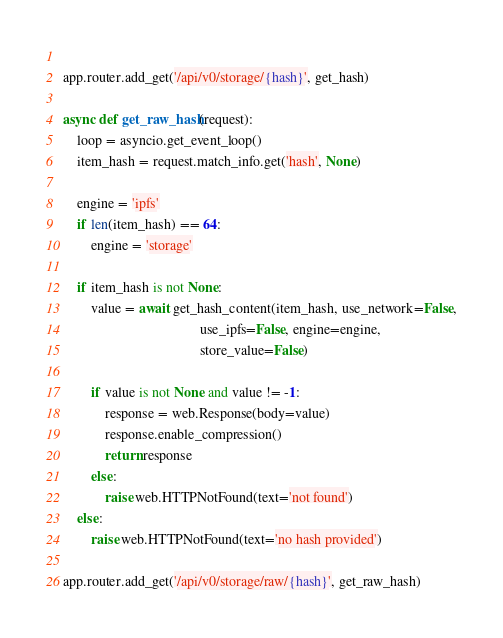Convert code to text. <code><loc_0><loc_0><loc_500><loc_500><_Python_>    
app.router.add_get('/api/v0/storage/{hash}', get_hash)

async def get_raw_hash(request):
    loop = asyncio.get_event_loop()
    item_hash = request.match_info.get('hash', None)
    
    engine = 'ipfs'
    if len(item_hash) == 64:
        engine = 'storage'
    
    if item_hash is not None:
        value = await get_hash_content(item_hash, use_network=False,
                                       use_ipfs=False, engine=engine,
                                       store_value=False)
    
        if value is not None and value != -1:
            response = web.Response(body=value)
            response.enable_compression()
            return response
        else:
            raise web.HTTPNotFound(text='not found')
    else:
        raise web.HTTPNotFound(text='no hash provided')
    
app.router.add_get('/api/v0/storage/raw/{hash}', get_raw_hash)</code> 